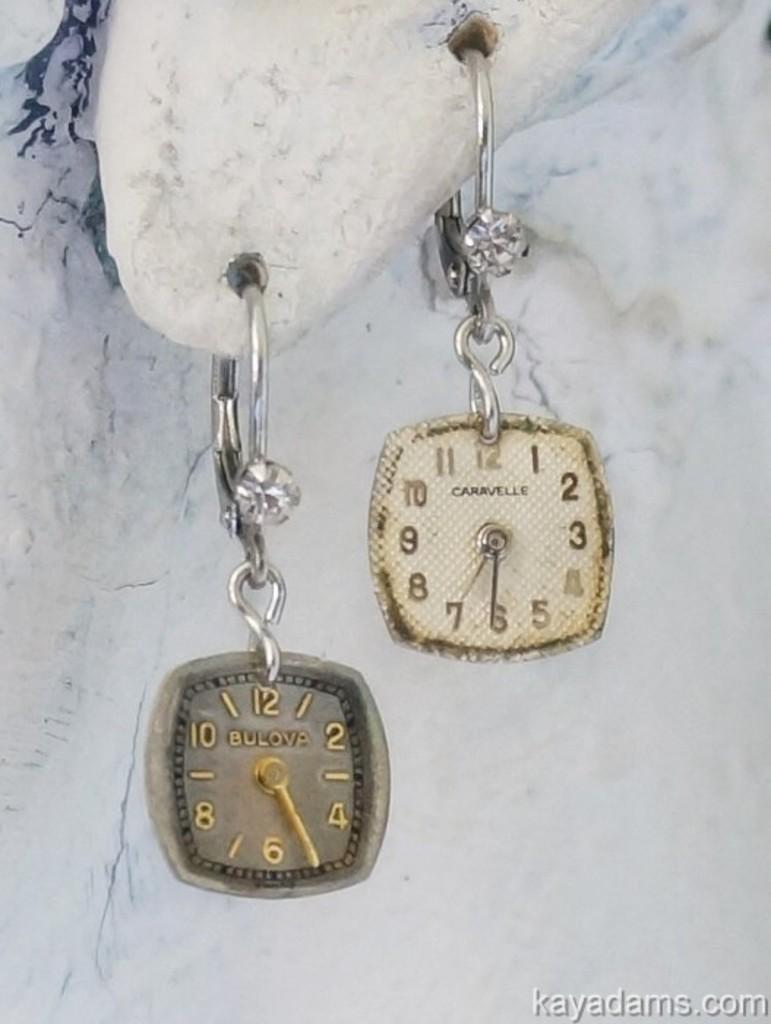What color is the wall that is visible in the image? The wall in the image is white. What type of objects can be seen hanging on the wall? There are keychains in the image. What direction are the vacationers heading in the image? There is no reference to vacationers or any direction in the image; it only features a white wall with keychains. 